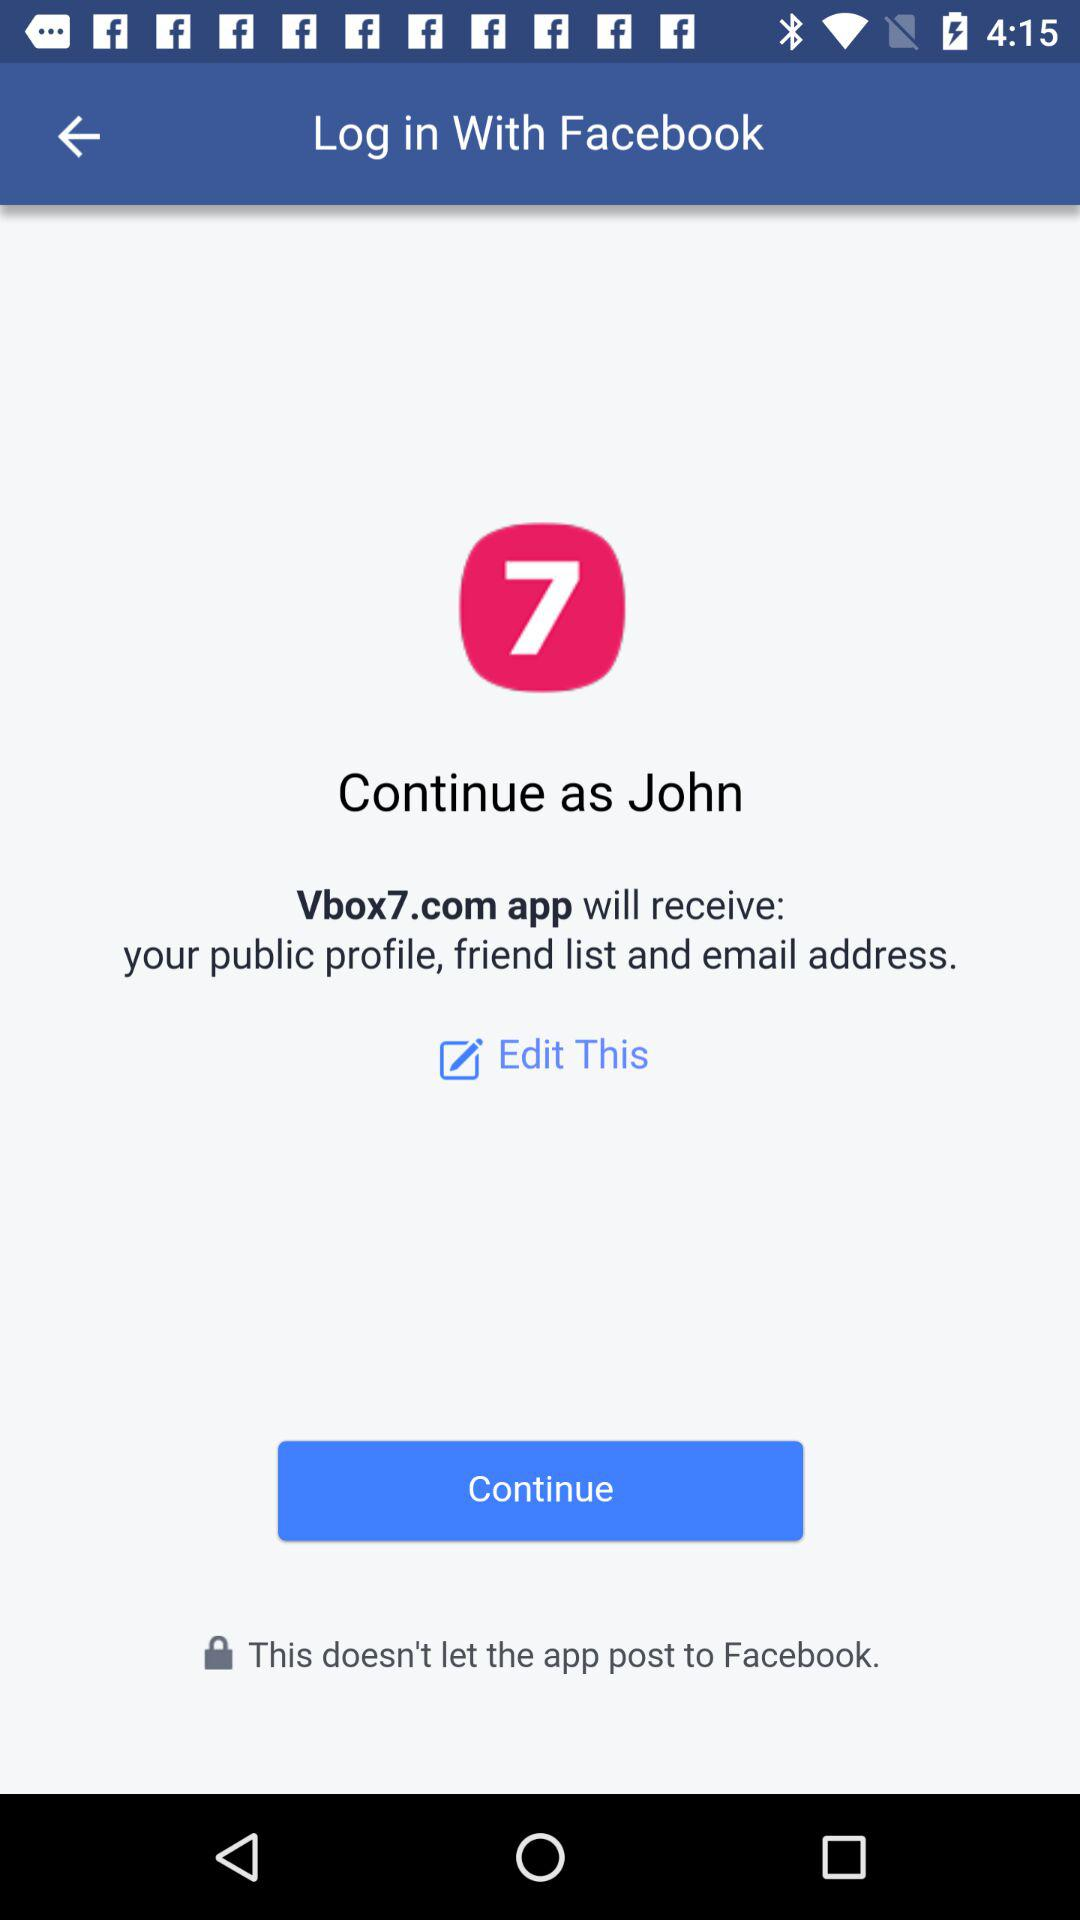What application will receive my public profile, friend list and email address? The application will receive a public profile, friend list and email address is "Vbox7.com". 